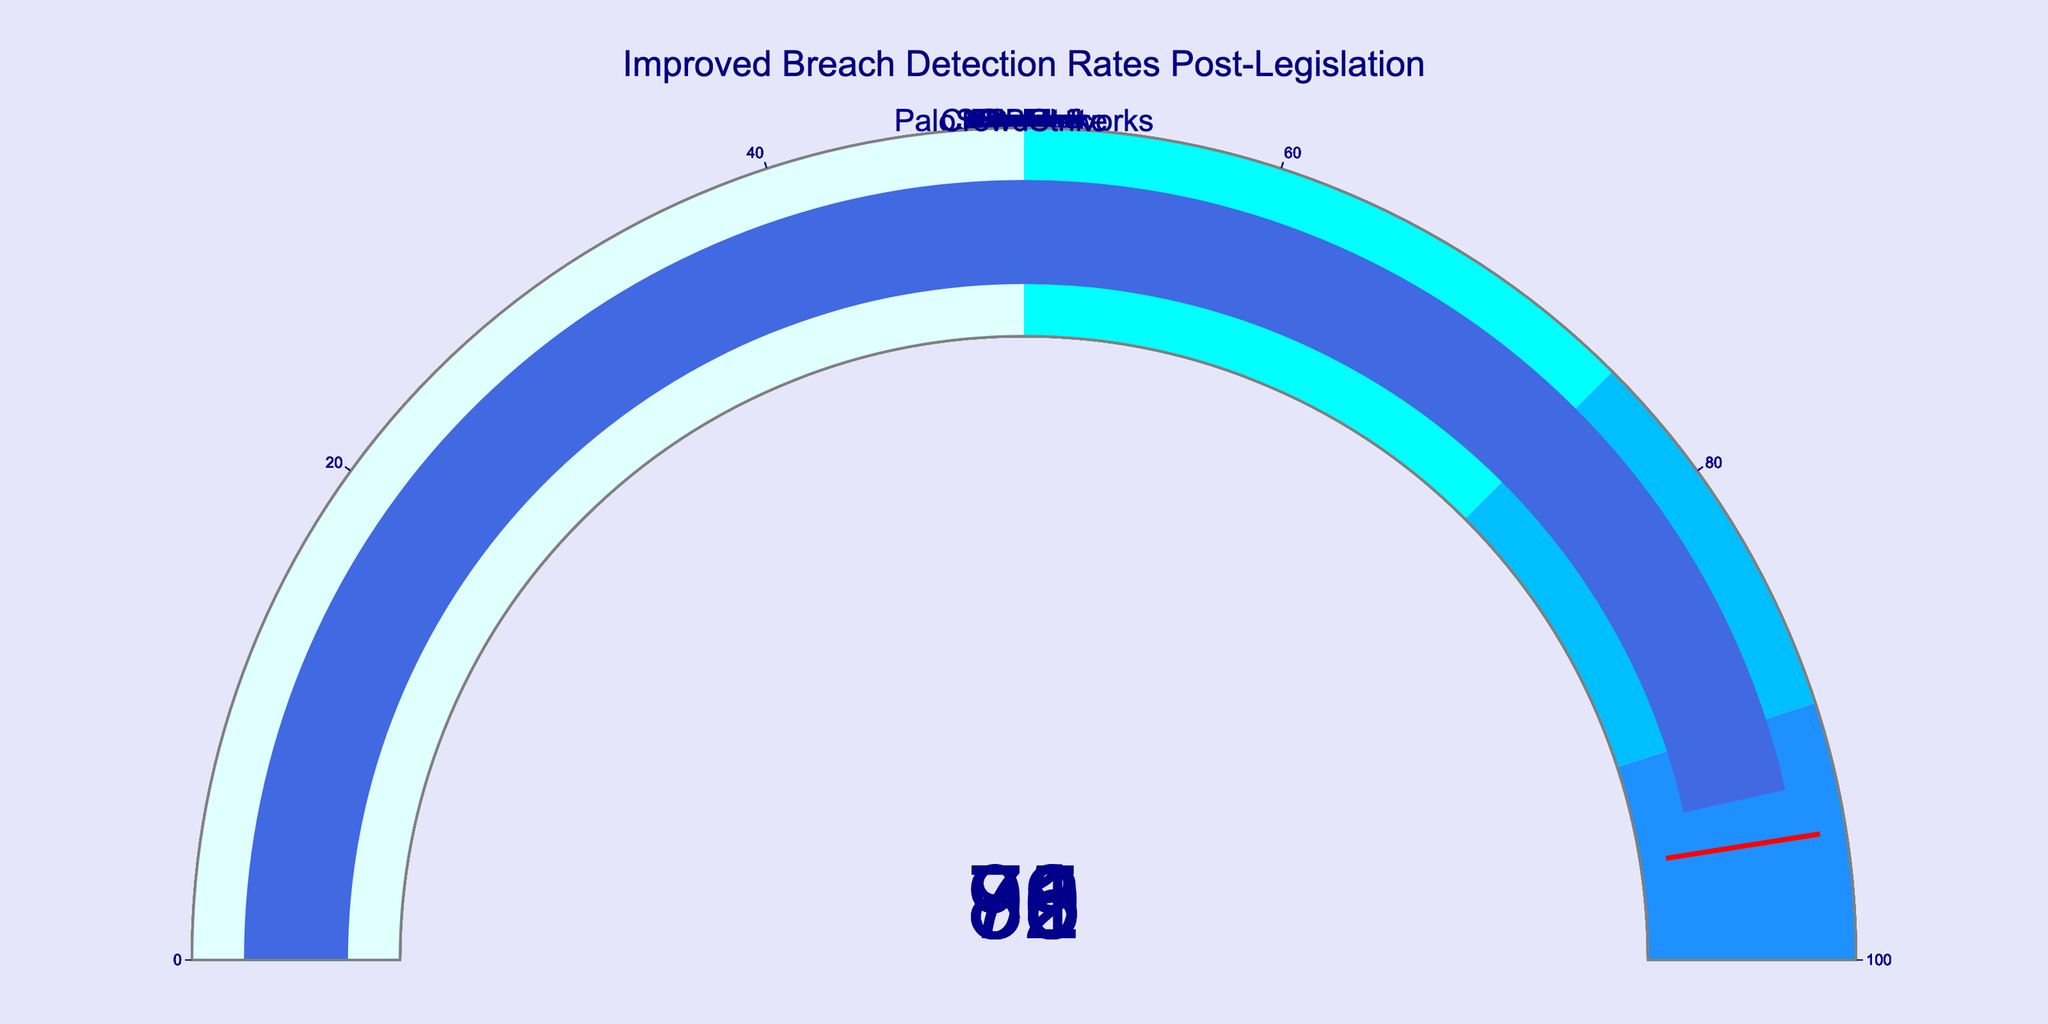What is the highest breach detection rate reported post-legislation? The figure shows the improved breach detection rates for several tech firms. The highest value among them is the breach detection rate reported by CrowdStrike, at 93.
Answer: 93 What is the average breach detection rate reported by these companies? To find the average, add all the breach detection rates and divide by the number of companies. The sum of the rates is 78 + 82 + 75 + 85 + 79 + 73 + 88 + 91 + 86 + 93 = 830. There are 10 companies, so the average is 830 / 10 = 83.
Answer: 83 What is the difference between the highest and the lowest breach detection rates reported? The highest breach detection rate is 93 (CrowdStrike) and the lowest is 73 (Oracle). The difference between these two values is 93 - 73 = 20.
Answer: 20 Which company reported a breach detection rate of 85? According to the figure, Cisco reported a breach detection rate of 85.
Answer: Cisco How many companies reported a breach detection rate of at least 80? To determine this, count the number of companies with breach detection rates of 80 and above. They are Microsoft (82), Cisco (85), Symantec (88), Palo Alto Networks (91), FireEye (86), and CrowdStrike (93). Thus, there are 6 companies in total.
Answer: 6 Is there a company with a breach detection rate below 75? If so, name it. Yes, Oracle has a breach detection rate below 75, specifically, 73.
Answer: Oracle Which companies reported a breach detection rate above the average? The average breach detection rate is 83. Companies above this rate are Cisco (85), Symantec (88), Palo Alto Networks (91), FireEye (86), and CrowdStrike (93).
Answer: Cisco, Symantec, Palo Alto Networks, FireEye, CrowdStrike What is the collective percentage improvement from all companies listed? The sum of the individual percentage rates is 830. Since percentages are already given as whole numbers and not fractions of a total, the collective percentage improvement for all companies combined is 830%.
Answer: 830% Which two companies have the closest breach detection rates, and what are those rates? IBM has a rate of 79, and Google has a rate of 78. The difference between these two rates is 1, which is the smallest difference observed among the companies.
Answer: IBM (79), Google (78) What is the median breach detection rate among the reported companies? To find the median, first order the rates: 73, 75, 78, 79, 82, 85, 86, 88, 91, 93. The median is the middle value of the ordered list, so here, with 10 data points, it's the average of the 5th and 6th values: (82 + 85) / 2 = 83.5.
Answer: 83.5 